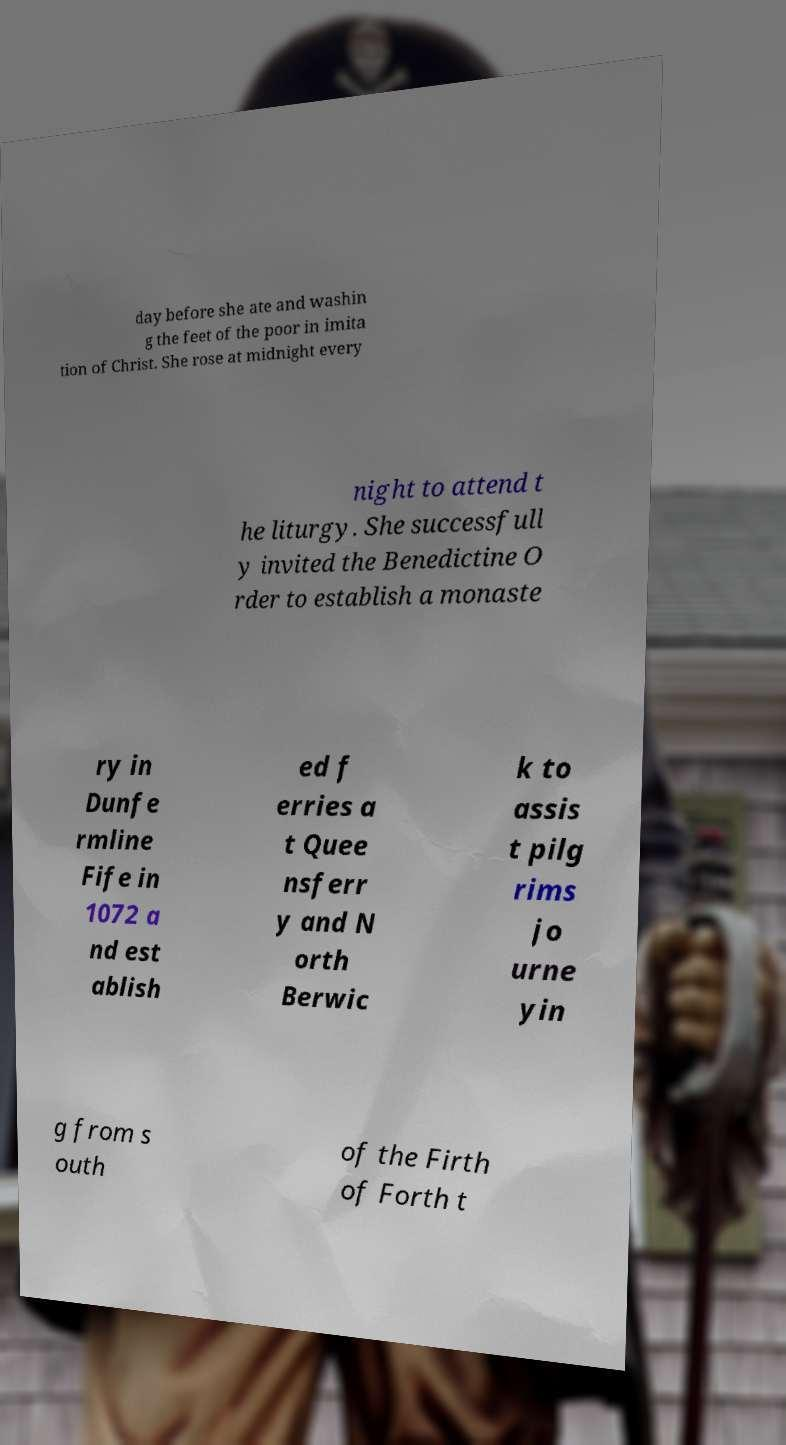Can you accurately transcribe the text from the provided image for me? day before she ate and washin g the feet of the poor in imita tion of Christ. She rose at midnight every night to attend t he liturgy. She successfull y invited the Benedictine O rder to establish a monaste ry in Dunfe rmline Fife in 1072 a nd est ablish ed f erries a t Quee nsferr y and N orth Berwic k to assis t pilg rims jo urne yin g from s outh of the Firth of Forth t 